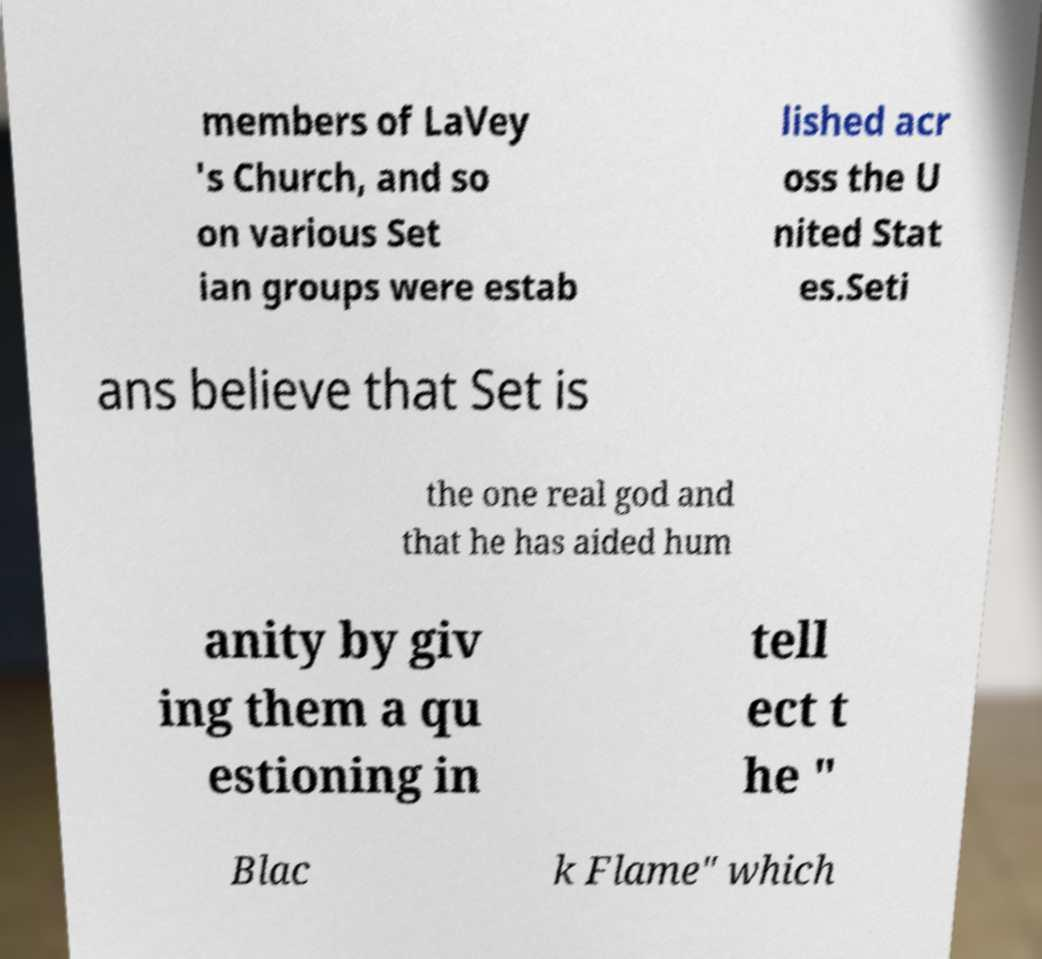Could you assist in decoding the text presented in this image and type it out clearly? members of LaVey 's Church, and so on various Set ian groups were estab lished acr oss the U nited Stat es.Seti ans believe that Set is the one real god and that he has aided hum anity by giv ing them a qu estioning in tell ect t he " Blac k Flame" which 